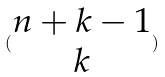Convert formula to latex. <formula><loc_0><loc_0><loc_500><loc_500>( \begin{matrix} n + k - 1 \\ k \end{matrix} )</formula> 